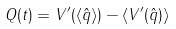<formula> <loc_0><loc_0><loc_500><loc_500>Q ( t ) = V ^ { \prime } ( \langle \hat { q } \rangle ) - \langle V ^ { \prime } ( \hat { q } ) \rangle</formula> 